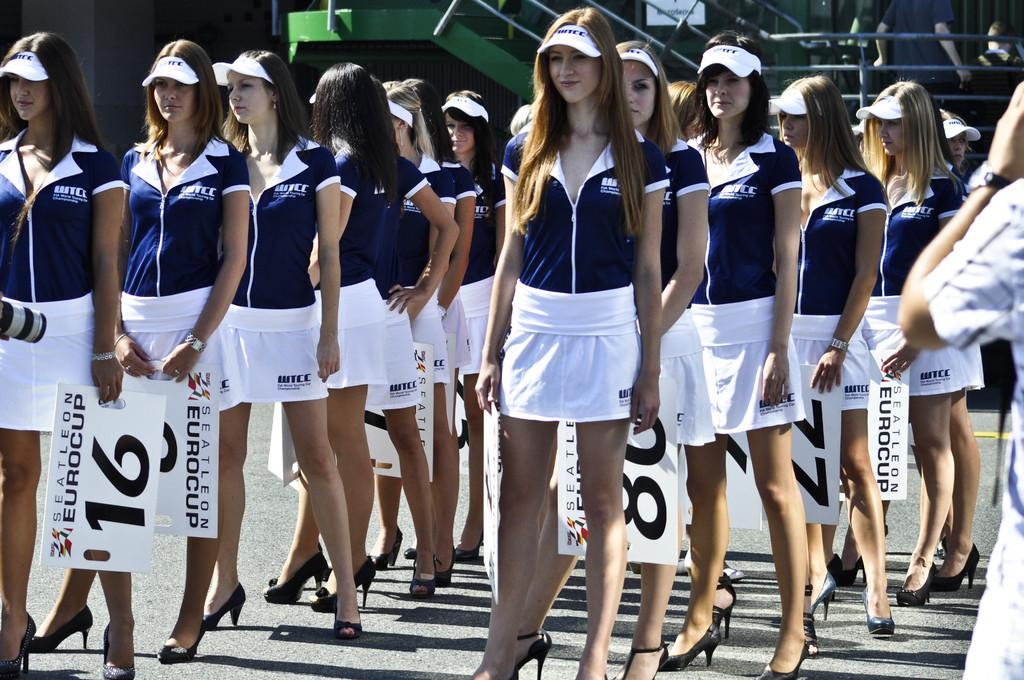Provide a one-sentence caption for the provided image. A group of pretty women hold numbered signs for the Eurocup. 